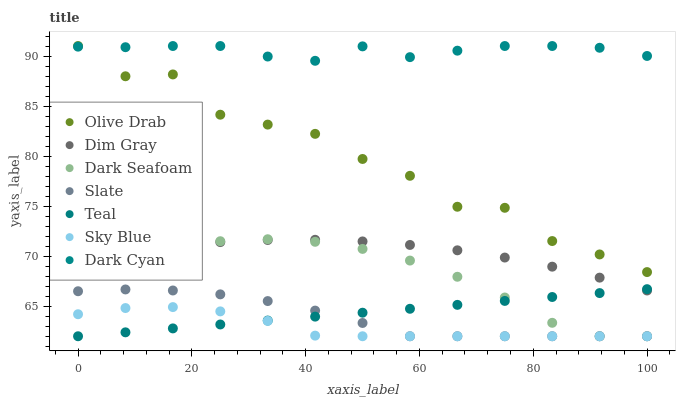Does Sky Blue have the minimum area under the curve?
Answer yes or no. Yes. Does Dark Cyan have the maximum area under the curve?
Answer yes or no. Yes. Does Slate have the minimum area under the curve?
Answer yes or no. No. Does Slate have the maximum area under the curve?
Answer yes or no. No. Is Teal the smoothest?
Answer yes or no. Yes. Is Olive Drab the roughest?
Answer yes or no. Yes. Is Slate the smoothest?
Answer yes or no. No. Is Slate the roughest?
Answer yes or no. No. Does Slate have the lowest value?
Answer yes or no. Yes. Does Dark Cyan have the lowest value?
Answer yes or no. No. Does Olive Drab have the highest value?
Answer yes or no. Yes. Does Slate have the highest value?
Answer yes or no. No. Is Sky Blue less than Dark Cyan?
Answer yes or no. Yes. Is Olive Drab greater than Sky Blue?
Answer yes or no. Yes. Does Slate intersect Sky Blue?
Answer yes or no. Yes. Is Slate less than Sky Blue?
Answer yes or no. No. Is Slate greater than Sky Blue?
Answer yes or no. No. Does Sky Blue intersect Dark Cyan?
Answer yes or no. No. 